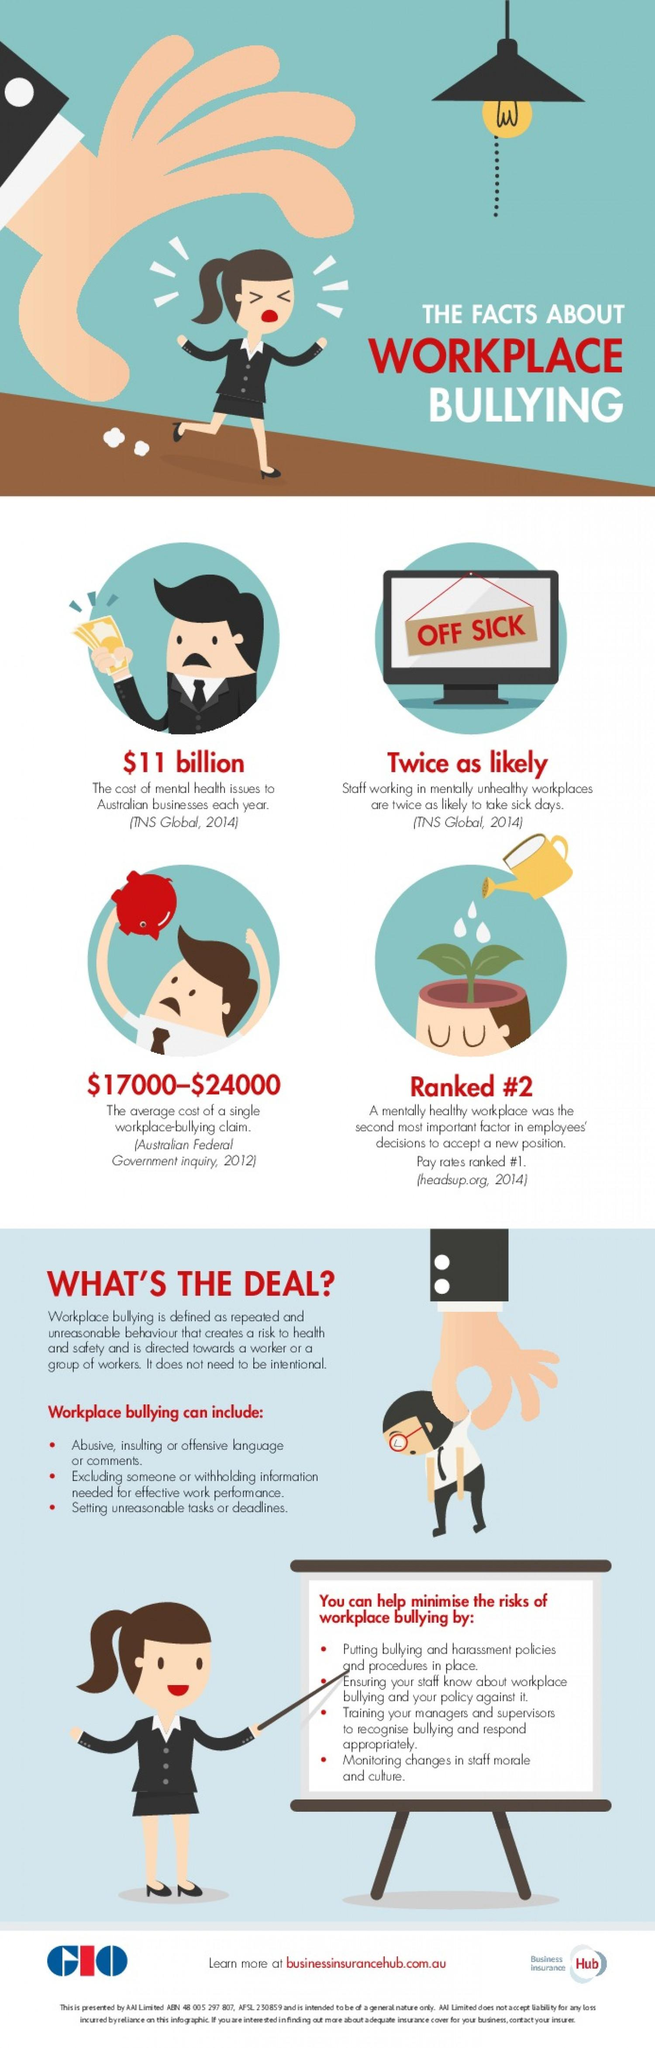Indicate a few pertinent items in this graphic. The most significant factor that influences employees' decisions to accept a new job is their pay rates. 